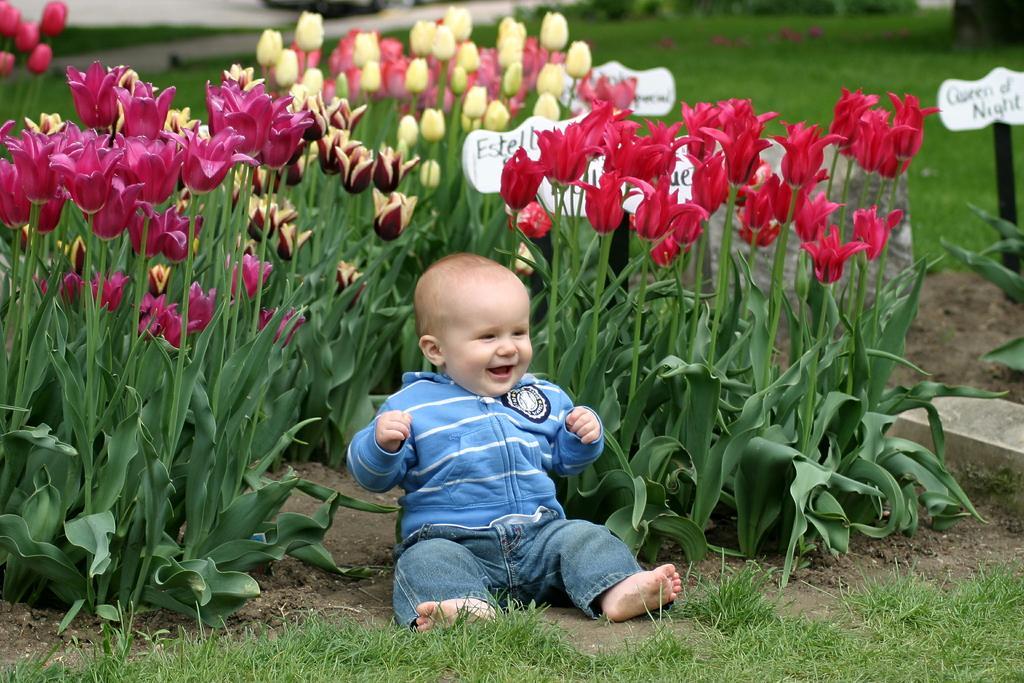How would you summarize this image in a sentence or two? In this image I can see a child is sitting on the ground and smiling. Here I can see the grass, flower plants and other objects on the ground. The background of the image is blurred. 